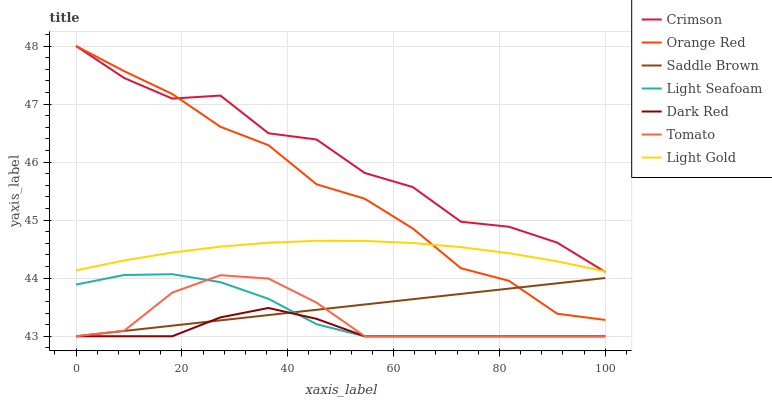Does Dark Red have the minimum area under the curve?
Answer yes or no. Yes. Does Crimson have the maximum area under the curve?
Answer yes or no. Yes. Does Saddle Brown have the minimum area under the curve?
Answer yes or no. No. Does Saddle Brown have the maximum area under the curve?
Answer yes or no. No. Is Saddle Brown the smoothest?
Answer yes or no. Yes. Is Crimson the roughest?
Answer yes or no. Yes. Is Dark Red the smoothest?
Answer yes or no. No. Is Dark Red the roughest?
Answer yes or no. No. Does Crimson have the lowest value?
Answer yes or no. No. Does Orange Red have the highest value?
Answer yes or no. Yes. Does Saddle Brown have the highest value?
Answer yes or no. No. Is Tomato less than Crimson?
Answer yes or no. Yes. Is Crimson greater than Tomato?
Answer yes or no. Yes. Does Crimson intersect Light Gold?
Answer yes or no. Yes. Is Crimson less than Light Gold?
Answer yes or no. No. Is Crimson greater than Light Gold?
Answer yes or no. No. Does Tomato intersect Crimson?
Answer yes or no. No. 